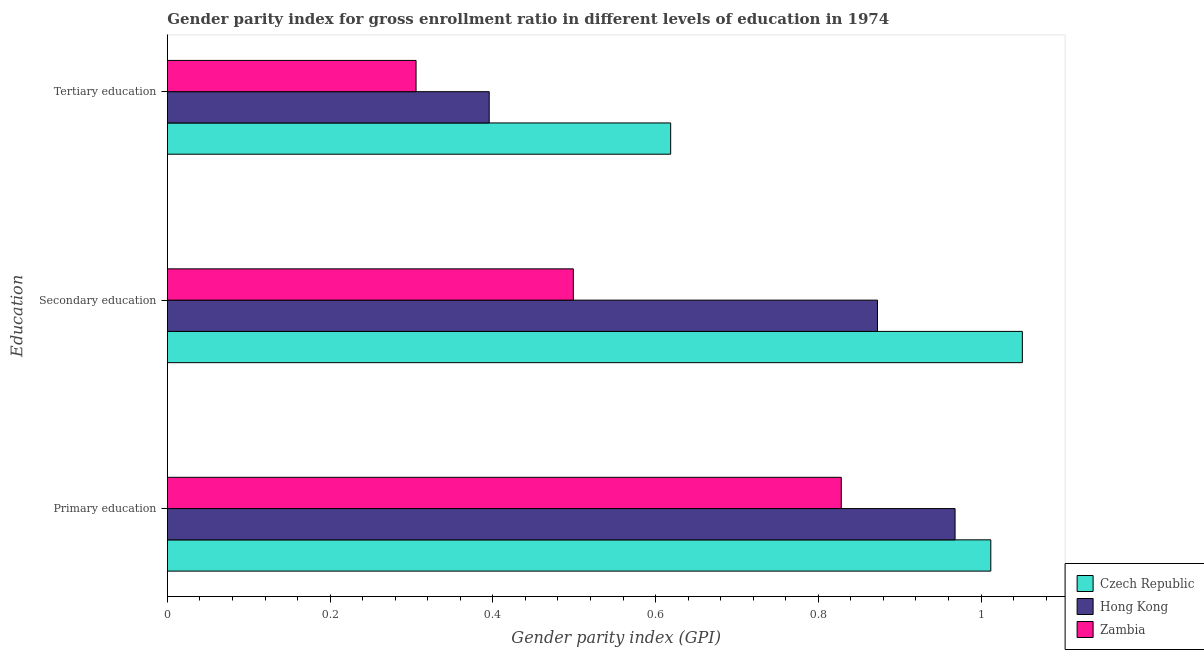How many different coloured bars are there?
Provide a short and direct response. 3. How many groups of bars are there?
Provide a succinct answer. 3. What is the label of the 1st group of bars from the top?
Provide a succinct answer. Tertiary education. What is the gender parity index in tertiary education in Hong Kong?
Provide a short and direct response. 0.4. Across all countries, what is the maximum gender parity index in tertiary education?
Your answer should be very brief. 0.62. Across all countries, what is the minimum gender parity index in tertiary education?
Your answer should be compact. 0.31. In which country was the gender parity index in primary education maximum?
Provide a succinct answer. Czech Republic. In which country was the gender parity index in primary education minimum?
Keep it short and to the point. Zambia. What is the total gender parity index in primary education in the graph?
Keep it short and to the point. 2.81. What is the difference between the gender parity index in secondary education in Czech Republic and that in Hong Kong?
Offer a terse response. 0.18. What is the difference between the gender parity index in tertiary education in Zambia and the gender parity index in primary education in Czech Republic?
Provide a short and direct response. -0.71. What is the average gender parity index in primary education per country?
Ensure brevity in your answer.  0.94. What is the difference between the gender parity index in primary education and gender parity index in secondary education in Zambia?
Provide a short and direct response. 0.33. In how many countries, is the gender parity index in tertiary education greater than 0.44 ?
Ensure brevity in your answer.  1. What is the ratio of the gender parity index in tertiary education in Czech Republic to that in Hong Kong?
Ensure brevity in your answer.  1.56. What is the difference between the highest and the second highest gender parity index in tertiary education?
Give a very brief answer. 0.22. What is the difference between the highest and the lowest gender parity index in secondary education?
Offer a terse response. 0.55. Is the sum of the gender parity index in tertiary education in Zambia and Hong Kong greater than the maximum gender parity index in primary education across all countries?
Give a very brief answer. No. What does the 2nd bar from the top in Tertiary education represents?
Offer a very short reply. Hong Kong. What does the 1st bar from the bottom in Primary education represents?
Give a very brief answer. Czech Republic. Is it the case that in every country, the sum of the gender parity index in primary education and gender parity index in secondary education is greater than the gender parity index in tertiary education?
Your answer should be compact. Yes. How many bars are there?
Ensure brevity in your answer.  9. Are all the bars in the graph horizontal?
Provide a succinct answer. Yes. How many countries are there in the graph?
Keep it short and to the point. 3. What is the difference between two consecutive major ticks on the X-axis?
Your response must be concise. 0.2. Are the values on the major ticks of X-axis written in scientific E-notation?
Give a very brief answer. No. Does the graph contain any zero values?
Offer a terse response. No. Does the graph contain grids?
Give a very brief answer. No. What is the title of the graph?
Provide a short and direct response. Gender parity index for gross enrollment ratio in different levels of education in 1974. What is the label or title of the X-axis?
Offer a very short reply. Gender parity index (GPI). What is the label or title of the Y-axis?
Keep it short and to the point. Education. What is the Gender parity index (GPI) in Czech Republic in Primary education?
Provide a succinct answer. 1.01. What is the Gender parity index (GPI) in Hong Kong in Primary education?
Your response must be concise. 0.97. What is the Gender parity index (GPI) in Zambia in Primary education?
Provide a short and direct response. 0.83. What is the Gender parity index (GPI) in Czech Republic in Secondary education?
Offer a terse response. 1.05. What is the Gender parity index (GPI) of Hong Kong in Secondary education?
Offer a very short reply. 0.87. What is the Gender parity index (GPI) in Zambia in Secondary education?
Offer a terse response. 0.5. What is the Gender parity index (GPI) in Czech Republic in Tertiary education?
Give a very brief answer. 0.62. What is the Gender parity index (GPI) of Hong Kong in Tertiary education?
Your answer should be compact. 0.4. What is the Gender parity index (GPI) in Zambia in Tertiary education?
Give a very brief answer. 0.31. Across all Education, what is the maximum Gender parity index (GPI) of Czech Republic?
Provide a short and direct response. 1.05. Across all Education, what is the maximum Gender parity index (GPI) of Hong Kong?
Ensure brevity in your answer.  0.97. Across all Education, what is the maximum Gender parity index (GPI) of Zambia?
Your answer should be compact. 0.83. Across all Education, what is the minimum Gender parity index (GPI) of Czech Republic?
Ensure brevity in your answer.  0.62. Across all Education, what is the minimum Gender parity index (GPI) of Hong Kong?
Offer a very short reply. 0.4. Across all Education, what is the minimum Gender parity index (GPI) of Zambia?
Provide a succinct answer. 0.31. What is the total Gender parity index (GPI) in Czech Republic in the graph?
Offer a terse response. 2.68. What is the total Gender parity index (GPI) in Hong Kong in the graph?
Offer a terse response. 2.24. What is the total Gender parity index (GPI) of Zambia in the graph?
Provide a short and direct response. 1.63. What is the difference between the Gender parity index (GPI) of Czech Republic in Primary education and that in Secondary education?
Make the answer very short. -0.04. What is the difference between the Gender parity index (GPI) of Hong Kong in Primary education and that in Secondary education?
Give a very brief answer. 0.1. What is the difference between the Gender parity index (GPI) in Zambia in Primary education and that in Secondary education?
Offer a terse response. 0.33. What is the difference between the Gender parity index (GPI) in Czech Republic in Primary education and that in Tertiary education?
Provide a short and direct response. 0.39. What is the difference between the Gender parity index (GPI) in Hong Kong in Primary education and that in Tertiary education?
Make the answer very short. 0.57. What is the difference between the Gender parity index (GPI) in Zambia in Primary education and that in Tertiary education?
Give a very brief answer. 0.52. What is the difference between the Gender parity index (GPI) in Czech Republic in Secondary education and that in Tertiary education?
Offer a very short reply. 0.43. What is the difference between the Gender parity index (GPI) in Hong Kong in Secondary education and that in Tertiary education?
Make the answer very short. 0.48. What is the difference between the Gender parity index (GPI) of Zambia in Secondary education and that in Tertiary education?
Provide a succinct answer. 0.19. What is the difference between the Gender parity index (GPI) of Czech Republic in Primary education and the Gender parity index (GPI) of Hong Kong in Secondary education?
Provide a short and direct response. 0.14. What is the difference between the Gender parity index (GPI) of Czech Republic in Primary education and the Gender parity index (GPI) of Zambia in Secondary education?
Your answer should be very brief. 0.51. What is the difference between the Gender parity index (GPI) in Hong Kong in Primary education and the Gender parity index (GPI) in Zambia in Secondary education?
Provide a short and direct response. 0.47. What is the difference between the Gender parity index (GPI) of Czech Republic in Primary education and the Gender parity index (GPI) of Hong Kong in Tertiary education?
Offer a very short reply. 0.62. What is the difference between the Gender parity index (GPI) in Czech Republic in Primary education and the Gender parity index (GPI) in Zambia in Tertiary education?
Ensure brevity in your answer.  0.71. What is the difference between the Gender parity index (GPI) in Hong Kong in Primary education and the Gender parity index (GPI) in Zambia in Tertiary education?
Give a very brief answer. 0.66. What is the difference between the Gender parity index (GPI) of Czech Republic in Secondary education and the Gender parity index (GPI) of Hong Kong in Tertiary education?
Make the answer very short. 0.66. What is the difference between the Gender parity index (GPI) of Czech Republic in Secondary education and the Gender parity index (GPI) of Zambia in Tertiary education?
Make the answer very short. 0.75. What is the difference between the Gender parity index (GPI) in Hong Kong in Secondary education and the Gender parity index (GPI) in Zambia in Tertiary education?
Ensure brevity in your answer.  0.57. What is the average Gender parity index (GPI) in Czech Republic per Education?
Keep it short and to the point. 0.89. What is the average Gender parity index (GPI) of Hong Kong per Education?
Ensure brevity in your answer.  0.75. What is the average Gender parity index (GPI) in Zambia per Education?
Your answer should be very brief. 0.54. What is the difference between the Gender parity index (GPI) of Czech Republic and Gender parity index (GPI) of Hong Kong in Primary education?
Provide a short and direct response. 0.04. What is the difference between the Gender parity index (GPI) in Czech Republic and Gender parity index (GPI) in Zambia in Primary education?
Keep it short and to the point. 0.18. What is the difference between the Gender parity index (GPI) of Hong Kong and Gender parity index (GPI) of Zambia in Primary education?
Keep it short and to the point. 0.14. What is the difference between the Gender parity index (GPI) in Czech Republic and Gender parity index (GPI) in Hong Kong in Secondary education?
Make the answer very short. 0.18. What is the difference between the Gender parity index (GPI) of Czech Republic and Gender parity index (GPI) of Zambia in Secondary education?
Give a very brief answer. 0.55. What is the difference between the Gender parity index (GPI) in Hong Kong and Gender parity index (GPI) in Zambia in Secondary education?
Offer a terse response. 0.37. What is the difference between the Gender parity index (GPI) in Czech Republic and Gender parity index (GPI) in Hong Kong in Tertiary education?
Ensure brevity in your answer.  0.22. What is the difference between the Gender parity index (GPI) in Czech Republic and Gender parity index (GPI) in Zambia in Tertiary education?
Keep it short and to the point. 0.31. What is the difference between the Gender parity index (GPI) of Hong Kong and Gender parity index (GPI) of Zambia in Tertiary education?
Provide a succinct answer. 0.09. What is the ratio of the Gender parity index (GPI) in Czech Republic in Primary education to that in Secondary education?
Keep it short and to the point. 0.96. What is the ratio of the Gender parity index (GPI) of Hong Kong in Primary education to that in Secondary education?
Provide a short and direct response. 1.11. What is the ratio of the Gender parity index (GPI) of Zambia in Primary education to that in Secondary education?
Keep it short and to the point. 1.66. What is the ratio of the Gender parity index (GPI) in Czech Republic in Primary education to that in Tertiary education?
Offer a terse response. 1.64. What is the ratio of the Gender parity index (GPI) in Hong Kong in Primary education to that in Tertiary education?
Ensure brevity in your answer.  2.45. What is the ratio of the Gender parity index (GPI) of Zambia in Primary education to that in Tertiary education?
Offer a terse response. 2.71. What is the ratio of the Gender parity index (GPI) in Czech Republic in Secondary education to that in Tertiary education?
Make the answer very short. 1.7. What is the ratio of the Gender parity index (GPI) of Hong Kong in Secondary education to that in Tertiary education?
Offer a terse response. 2.21. What is the ratio of the Gender parity index (GPI) in Zambia in Secondary education to that in Tertiary education?
Provide a succinct answer. 1.63. What is the difference between the highest and the second highest Gender parity index (GPI) in Czech Republic?
Your response must be concise. 0.04. What is the difference between the highest and the second highest Gender parity index (GPI) in Hong Kong?
Keep it short and to the point. 0.1. What is the difference between the highest and the second highest Gender parity index (GPI) in Zambia?
Offer a terse response. 0.33. What is the difference between the highest and the lowest Gender parity index (GPI) of Czech Republic?
Provide a succinct answer. 0.43. What is the difference between the highest and the lowest Gender parity index (GPI) of Hong Kong?
Provide a short and direct response. 0.57. What is the difference between the highest and the lowest Gender parity index (GPI) in Zambia?
Keep it short and to the point. 0.52. 